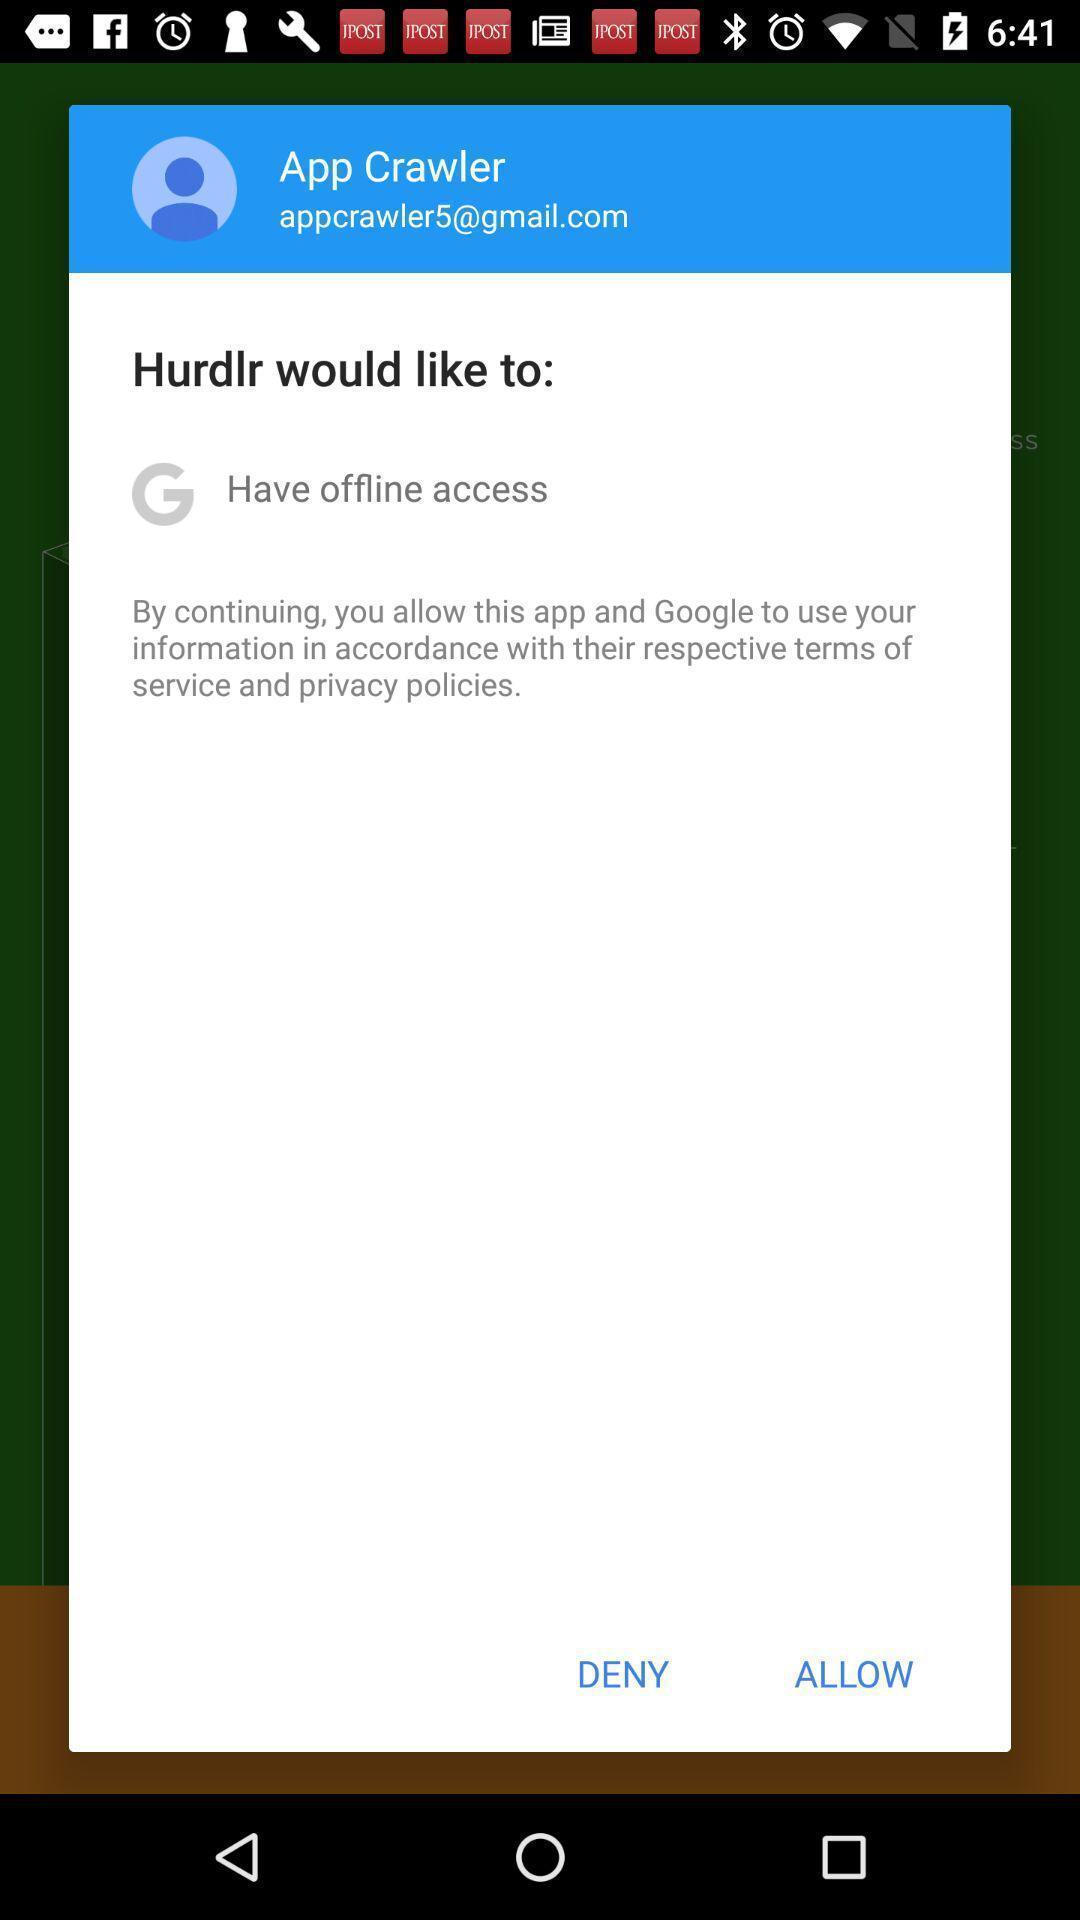Describe the key features of this screenshot. Pop up screen of username and permission for privacy policy. 